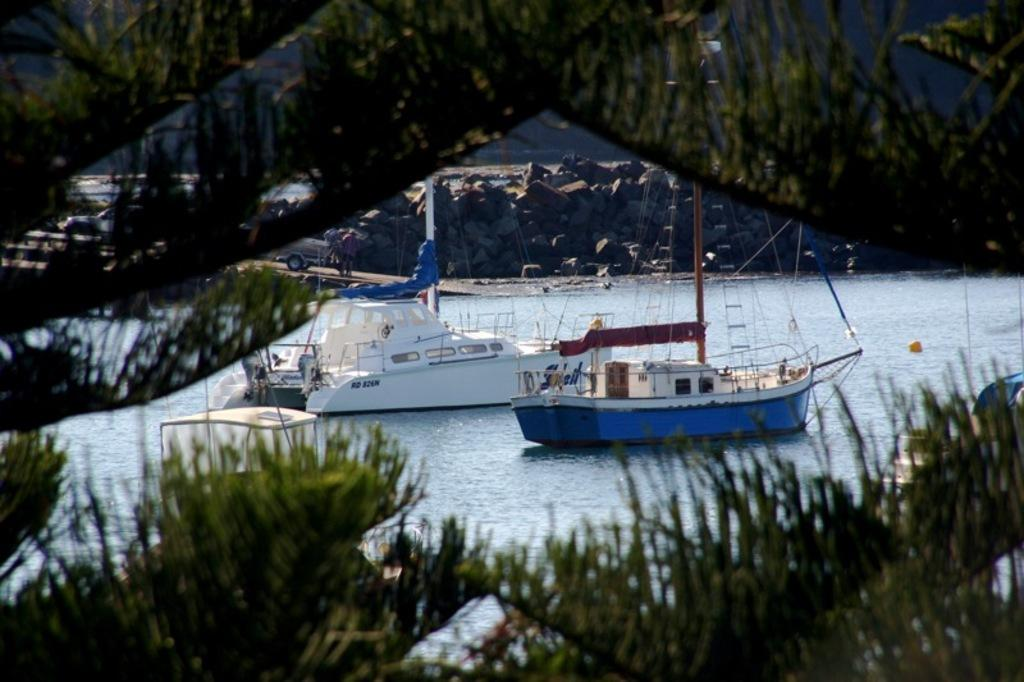What is on the water in the image? There are boats on the water in the image. What can be seen in the front of the image? Trees are visible in the front of the image. What is located in the background of the image? There is a vehicle and people in the background of the image. What type of natural feature is present in the background of the image? Rocks are present in the background of the image. What type of nest can be seen in the image? There is no nest present in the image. What does the water smell like in the image? The image does not provide any information about the smell of the water. 